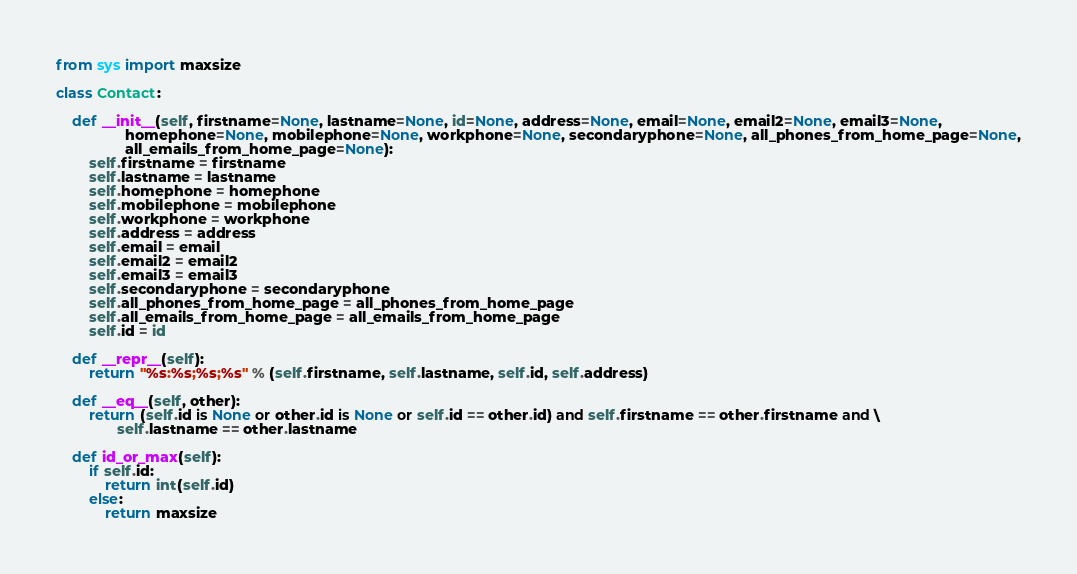Convert code to text. <code><loc_0><loc_0><loc_500><loc_500><_Python_>from sys import maxsize

class Contact:

    def __init__(self, firstname=None, lastname=None, id=None, address=None, email=None, email2=None, email3=None,
                 homephone=None, mobilephone=None, workphone=None, secondaryphone=None, all_phones_from_home_page=None,
                 all_emails_from_home_page=None):
        self.firstname = firstname
        self.lastname = lastname
        self.homephone = homephone
        self.mobilephone = mobilephone
        self.workphone = workphone
        self.address = address
        self.email = email
        self.email2 = email2
        self.email3 = email3
        self.secondaryphone = secondaryphone
        self.all_phones_from_home_page = all_phones_from_home_page
        self.all_emails_from_home_page = all_emails_from_home_page
        self.id = id

    def __repr__(self):
        return "%s:%s;%s;%s" % (self.firstname, self.lastname, self.id, self.address)

    def __eq__(self, other):
        return (self.id is None or other.id is None or self.id == other.id) and self.firstname == other.firstname and \
               self.lastname == other.lastname

    def id_or_max(self):
        if self.id:
            return int(self.id)
        else:
            return maxsize</code> 